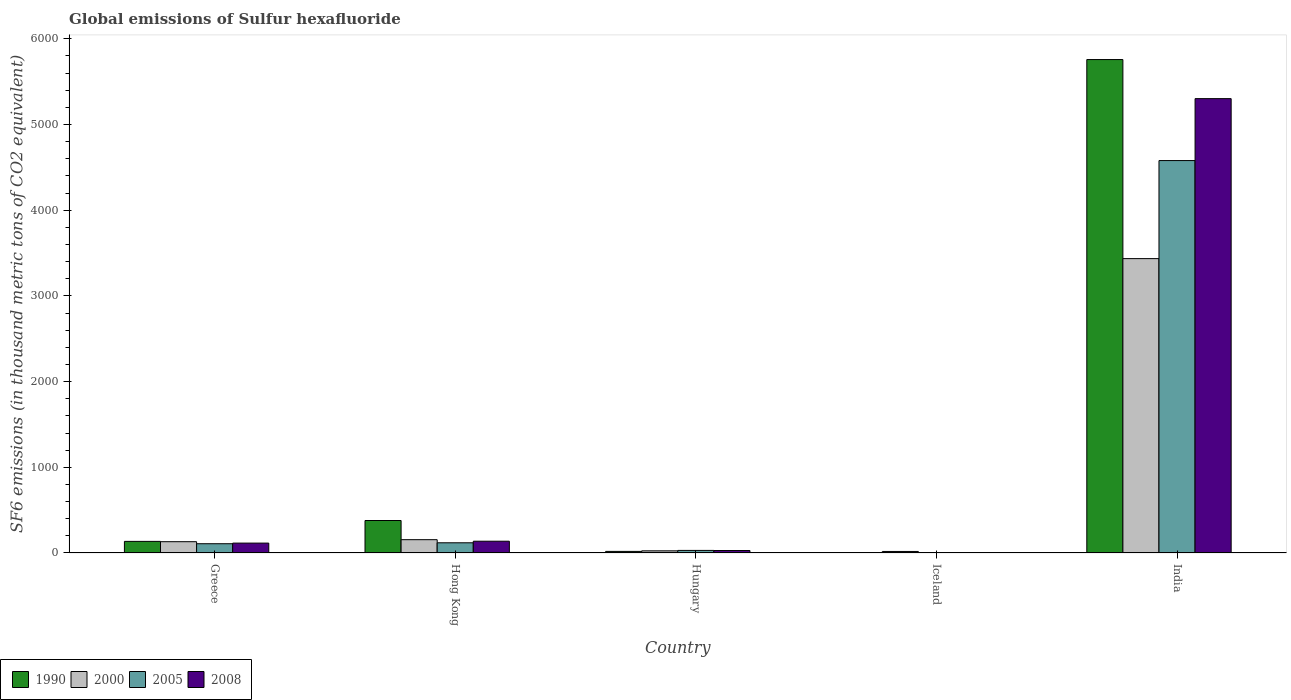How many groups of bars are there?
Provide a succinct answer. 5. Are the number of bars per tick equal to the number of legend labels?
Provide a short and direct response. Yes. How many bars are there on the 1st tick from the right?
Your answer should be compact. 4. What is the label of the 3rd group of bars from the left?
Your answer should be very brief. Hungary. What is the global emissions of Sulfur hexafluoride in 2005 in Iceland?
Ensure brevity in your answer.  3.5. Across all countries, what is the maximum global emissions of Sulfur hexafluoride in 2008?
Give a very brief answer. 5301.4. What is the total global emissions of Sulfur hexafluoride in 2000 in the graph?
Ensure brevity in your answer.  3764.9. What is the difference between the global emissions of Sulfur hexafluoride in 2008 in Greece and that in Hungary?
Provide a succinct answer. 86.5. What is the difference between the global emissions of Sulfur hexafluoride in 2005 in Greece and the global emissions of Sulfur hexafluoride in 1990 in India?
Your response must be concise. -5649.4. What is the average global emissions of Sulfur hexafluoride in 2008 per country?
Offer a terse response. 1117.42. What is the difference between the global emissions of Sulfur hexafluoride of/in 2008 and global emissions of Sulfur hexafluoride of/in 1990 in Hungary?
Your answer should be compact. 10.3. In how many countries, is the global emissions of Sulfur hexafluoride in 2000 greater than 800 thousand metric tons?
Provide a short and direct response. 1. What is the ratio of the global emissions of Sulfur hexafluoride in 2000 in Hong Kong to that in India?
Provide a succinct answer. 0.05. Is the global emissions of Sulfur hexafluoride in 2008 in Hungary less than that in Iceland?
Your answer should be very brief. No. Is the difference between the global emissions of Sulfur hexafluoride in 2008 in Hong Kong and India greater than the difference between the global emissions of Sulfur hexafluoride in 1990 in Hong Kong and India?
Keep it short and to the point. Yes. What is the difference between the highest and the second highest global emissions of Sulfur hexafluoride in 2000?
Give a very brief answer. 3279.4. What is the difference between the highest and the lowest global emissions of Sulfur hexafluoride in 2008?
Your response must be concise. 5297.4. In how many countries, is the global emissions of Sulfur hexafluoride in 2005 greater than the average global emissions of Sulfur hexafluoride in 2005 taken over all countries?
Give a very brief answer. 1. Is the sum of the global emissions of Sulfur hexafluoride in 2005 in Hong Kong and Hungary greater than the maximum global emissions of Sulfur hexafluoride in 2008 across all countries?
Offer a very short reply. No. What does the 3rd bar from the left in Greece represents?
Ensure brevity in your answer.  2005. What does the 1st bar from the right in India represents?
Make the answer very short. 2008. Does the graph contain any zero values?
Offer a terse response. No. What is the title of the graph?
Make the answer very short. Global emissions of Sulfur hexafluoride. What is the label or title of the Y-axis?
Keep it short and to the point. SF6 emissions (in thousand metric tons of CO2 equivalent). What is the SF6 emissions (in thousand metric tons of CO2 equivalent) of 1990 in Greece?
Provide a short and direct response. 135.4. What is the SF6 emissions (in thousand metric tons of CO2 equivalent) of 2000 in Greece?
Your response must be concise. 131.8. What is the SF6 emissions (in thousand metric tons of CO2 equivalent) in 2005 in Greece?
Offer a terse response. 108.1. What is the SF6 emissions (in thousand metric tons of CO2 equivalent) in 2008 in Greece?
Your answer should be compact. 115.4. What is the SF6 emissions (in thousand metric tons of CO2 equivalent) of 1990 in Hong Kong?
Give a very brief answer. 379. What is the SF6 emissions (in thousand metric tons of CO2 equivalent) in 2000 in Hong Kong?
Ensure brevity in your answer.  155.3. What is the SF6 emissions (in thousand metric tons of CO2 equivalent) of 2005 in Hong Kong?
Ensure brevity in your answer.  119. What is the SF6 emissions (in thousand metric tons of CO2 equivalent) in 2008 in Hong Kong?
Ensure brevity in your answer.  137.4. What is the SF6 emissions (in thousand metric tons of CO2 equivalent) of 1990 in Hungary?
Offer a very short reply. 18.6. What is the SF6 emissions (in thousand metric tons of CO2 equivalent) of 2000 in Hungary?
Your answer should be very brief. 25.2. What is the SF6 emissions (in thousand metric tons of CO2 equivalent) in 2008 in Hungary?
Offer a terse response. 28.9. What is the SF6 emissions (in thousand metric tons of CO2 equivalent) of 2000 in Iceland?
Your response must be concise. 17.9. What is the SF6 emissions (in thousand metric tons of CO2 equivalent) of 1990 in India?
Offer a very short reply. 5757.5. What is the SF6 emissions (in thousand metric tons of CO2 equivalent) of 2000 in India?
Your response must be concise. 3434.7. What is the SF6 emissions (in thousand metric tons of CO2 equivalent) of 2005 in India?
Provide a short and direct response. 4578.7. What is the SF6 emissions (in thousand metric tons of CO2 equivalent) of 2008 in India?
Ensure brevity in your answer.  5301.4. Across all countries, what is the maximum SF6 emissions (in thousand metric tons of CO2 equivalent) in 1990?
Your response must be concise. 5757.5. Across all countries, what is the maximum SF6 emissions (in thousand metric tons of CO2 equivalent) in 2000?
Provide a succinct answer. 3434.7. Across all countries, what is the maximum SF6 emissions (in thousand metric tons of CO2 equivalent) in 2005?
Offer a terse response. 4578.7. Across all countries, what is the maximum SF6 emissions (in thousand metric tons of CO2 equivalent) in 2008?
Your answer should be compact. 5301.4. Across all countries, what is the minimum SF6 emissions (in thousand metric tons of CO2 equivalent) in 2005?
Ensure brevity in your answer.  3.5. What is the total SF6 emissions (in thousand metric tons of CO2 equivalent) of 1990 in the graph?
Provide a short and direct response. 6294. What is the total SF6 emissions (in thousand metric tons of CO2 equivalent) of 2000 in the graph?
Make the answer very short. 3764.9. What is the total SF6 emissions (in thousand metric tons of CO2 equivalent) in 2005 in the graph?
Keep it short and to the point. 4839.3. What is the total SF6 emissions (in thousand metric tons of CO2 equivalent) in 2008 in the graph?
Your response must be concise. 5587.1. What is the difference between the SF6 emissions (in thousand metric tons of CO2 equivalent) in 1990 in Greece and that in Hong Kong?
Your answer should be compact. -243.6. What is the difference between the SF6 emissions (in thousand metric tons of CO2 equivalent) of 2000 in Greece and that in Hong Kong?
Ensure brevity in your answer.  -23.5. What is the difference between the SF6 emissions (in thousand metric tons of CO2 equivalent) in 2005 in Greece and that in Hong Kong?
Your answer should be very brief. -10.9. What is the difference between the SF6 emissions (in thousand metric tons of CO2 equivalent) of 2008 in Greece and that in Hong Kong?
Your response must be concise. -22. What is the difference between the SF6 emissions (in thousand metric tons of CO2 equivalent) in 1990 in Greece and that in Hungary?
Your response must be concise. 116.8. What is the difference between the SF6 emissions (in thousand metric tons of CO2 equivalent) in 2000 in Greece and that in Hungary?
Your response must be concise. 106.6. What is the difference between the SF6 emissions (in thousand metric tons of CO2 equivalent) in 2005 in Greece and that in Hungary?
Your answer should be very brief. 78.1. What is the difference between the SF6 emissions (in thousand metric tons of CO2 equivalent) of 2008 in Greece and that in Hungary?
Provide a succinct answer. 86.5. What is the difference between the SF6 emissions (in thousand metric tons of CO2 equivalent) in 1990 in Greece and that in Iceland?
Offer a very short reply. 131.9. What is the difference between the SF6 emissions (in thousand metric tons of CO2 equivalent) in 2000 in Greece and that in Iceland?
Provide a short and direct response. 113.9. What is the difference between the SF6 emissions (in thousand metric tons of CO2 equivalent) of 2005 in Greece and that in Iceland?
Offer a very short reply. 104.6. What is the difference between the SF6 emissions (in thousand metric tons of CO2 equivalent) in 2008 in Greece and that in Iceland?
Offer a very short reply. 111.4. What is the difference between the SF6 emissions (in thousand metric tons of CO2 equivalent) in 1990 in Greece and that in India?
Offer a terse response. -5622.1. What is the difference between the SF6 emissions (in thousand metric tons of CO2 equivalent) in 2000 in Greece and that in India?
Provide a succinct answer. -3302.9. What is the difference between the SF6 emissions (in thousand metric tons of CO2 equivalent) in 2005 in Greece and that in India?
Offer a very short reply. -4470.6. What is the difference between the SF6 emissions (in thousand metric tons of CO2 equivalent) of 2008 in Greece and that in India?
Offer a very short reply. -5186. What is the difference between the SF6 emissions (in thousand metric tons of CO2 equivalent) of 1990 in Hong Kong and that in Hungary?
Make the answer very short. 360.4. What is the difference between the SF6 emissions (in thousand metric tons of CO2 equivalent) of 2000 in Hong Kong and that in Hungary?
Provide a short and direct response. 130.1. What is the difference between the SF6 emissions (in thousand metric tons of CO2 equivalent) of 2005 in Hong Kong and that in Hungary?
Make the answer very short. 89. What is the difference between the SF6 emissions (in thousand metric tons of CO2 equivalent) of 2008 in Hong Kong and that in Hungary?
Offer a terse response. 108.5. What is the difference between the SF6 emissions (in thousand metric tons of CO2 equivalent) of 1990 in Hong Kong and that in Iceland?
Offer a very short reply. 375.5. What is the difference between the SF6 emissions (in thousand metric tons of CO2 equivalent) in 2000 in Hong Kong and that in Iceland?
Give a very brief answer. 137.4. What is the difference between the SF6 emissions (in thousand metric tons of CO2 equivalent) of 2005 in Hong Kong and that in Iceland?
Offer a very short reply. 115.5. What is the difference between the SF6 emissions (in thousand metric tons of CO2 equivalent) in 2008 in Hong Kong and that in Iceland?
Give a very brief answer. 133.4. What is the difference between the SF6 emissions (in thousand metric tons of CO2 equivalent) in 1990 in Hong Kong and that in India?
Make the answer very short. -5378.5. What is the difference between the SF6 emissions (in thousand metric tons of CO2 equivalent) of 2000 in Hong Kong and that in India?
Your answer should be compact. -3279.4. What is the difference between the SF6 emissions (in thousand metric tons of CO2 equivalent) in 2005 in Hong Kong and that in India?
Provide a succinct answer. -4459.7. What is the difference between the SF6 emissions (in thousand metric tons of CO2 equivalent) in 2008 in Hong Kong and that in India?
Offer a very short reply. -5164. What is the difference between the SF6 emissions (in thousand metric tons of CO2 equivalent) in 1990 in Hungary and that in Iceland?
Offer a very short reply. 15.1. What is the difference between the SF6 emissions (in thousand metric tons of CO2 equivalent) of 2000 in Hungary and that in Iceland?
Your response must be concise. 7.3. What is the difference between the SF6 emissions (in thousand metric tons of CO2 equivalent) of 2005 in Hungary and that in Iceland?
Make the answer very short. 26.5. What is the difference between the SF6 emissions (in thousand metric tons of CO2 equivalent) of 2008 in Hungary and that in Iceland?
Keep it short and to the point. 24.9. What is the difference between the SF6 emissions (in thousand metric tons of CO2 equivalent) in 1990 in Hungary and that in India?
Your response must be concise. -5738.9. What is the difference between the SF6 emissions (in thousand metric tons of CO2 equivalent) of 2000 in Hungary and that in India?
Offer a very short reply. -3409.5. What is the difference between the SF6 emissions (in thousand metric tons of CO2 equivalent) in 2005 in Hungary and that in India?
Your response must be concise. -4548.7. What is the difference between the SF6 emissions (in thousand metric tons of CO2 equivalent) in 2008 in Hungary and that in India?
Your response must be concise. -5272.5. What is the difference between the SF6 emissions (in thousand metric tons of CO2 equivalent) in 1990 in Iceland and that in India?
Your response must be concise. -5754. What is the difference between the SF6 emissions (in thousand metric tons of CO2 equivalent) in 2000 in Iceland and that in India?
Make the answer very short. -3416.8. What is the difference between the SF6 emissions (in thousand metric tons of CO2 equivalent) of 2005 in Iceland and that in India?
Your response must be concise. -4575.2. What is the difference between the SF6 emissions (in thousand metric tons of CO2 equivalent) in 2008 in Iceland and that in India?
Make the answer very short. -5297.4. What is the difference between the SF6 emissions (in thousand metric tons of CO2 equivalent) in 1990 in Greece and the SF6 emissions (in thousand metric tons of CO2 equivalent) in 2000 in Hong Kong?
Your answer should be compact. -19.9. What is the difference between the SF6 emissions (in thousand metric tons of CO2 equivalent) of 1990 in Greece and the SF6 emissions (in thousand metric tons of CO2 equivalent) of 2005 in Hong Kong?
Offer a terse response. 16.4. What is the difference between the SF6 emissions (in thousand metric tons of CO2 equivalent) of 1990 in Greece and the SF6 emissions (in thousand metric tons of CO2 equivalent) of 2008 in Hong Kong?
Give a very brief answer. -2. What is the difference between the SF6 emissions (in thousand metric tons of CO2 equivalent) of 2000 in Greece and the SF6 emissions (in thousand metric tons of CO2 equivalent) of 2005 in Hong Kong?
Offer a terse response. 12.8. What is the difference between the SF6 emissions (in thousand metric tons of CO2 equivalent) of 2005 in Greece and the SF6 emissions (in thousand metric tons of CO2 equivalent) of 2008 in Hong Kong?
Ensure brevity in your answer.  -29.3. What is the difference between the SF6 emissions (in thousand metric tons of CO2 equivalent) in 1990 in Greece and the SF6 emissions (in thousand metric tons of CO2 equivalent) in 2000 in Hungary?
Ensure brevity in your answer.  110.2. What is the difference between the SF6 emissions (in thousand metric tons of CO2 equivalent) in 1990 in Greece and the SF6 emissions (in thousand metric tons of CO2 equivalent) in 2005 in Hungary?
Give a very brief answer. 105.4. What is the difference between the SF6 emissions (in thousand metric tons of CO2 equivalent) in 1990 in Greece and the SF6 emissions (in thousand metric tons of CO2 equivalent) in 2008 in Hungary?
Keep it short and to the point. 106.5. What is the difference between the SF6 emissions (in thousand metric tons of CO2 equivalent) of 2000 in Greece and the SF6 emissions (in thousand metric tons of CO2 equivalent) of 2005 in Hungary?
Make the answer very short. 101.8. What is the difference between the SF6 emissions (in thousand metric tons of CO2 equivalent) in 2000 in Greece and the SF6 emissions (in thousand metric tons of CO2 equivalent) in 2008 in Hungary?
Offer a terse response. 102.9. What is the difference between the SF6 emissions (in thousand metric tons of CO2 equivalent) of 2005 in Greece and the SF6 emissions (in thousand metric tons of CO2 equivalent) of 2008 in Hungary?
Your answer should be very brief. 79.2. What is the difference between the SF6 emissions (in thousand metric tons of CO2 equivalent) of 1990 in Greece and the SF6 emissions (in thousand metric tons of CO2 equivalent) of 2000 in Iceland?
Offer a very short reply. 117.5. What is the difference between the SF6 emissions (in thousand metric tons of CO2 equivalent) of 1990 in Greece and the SF6 emissions (in thousand metric tons of CO2 equivalent) of 2005 in Iceland?
Offer a very short reply. 131.9. What is the difference between the SF6 emissions (in thousand metric tons of CO2 equivalent) of 1990 in Greece and the SF6 emissions (in thousand metric tons of CO2 equivalent) of 2008 in Iceland?
Give a very brief answer. 131.4. What is the difference between the SF6 emissions (in thousand metric tons of CO2 equivalent) of 2000 in Greece and the SF6 emissions (in thousand metric tons of CO2 equivalent) of 2005 in Iceland?
Your answer should be compact. 128.3. What is the difference between the SF6 emissions (in thousand metric tons of CO2 equivalent) of 2000 in Greece and the SF6 emissions (in thousand metric tons of CO2 equivalent) of 2008 in Iceland?
Ensure brevity in your answer.  127.8. What is the difference between the SF6 emissions (in thousand metric tons of CO2 equivalent) of 2005 in Greece and the SF6 emissions (in thousand metric tons of CO2 equivalent) of 2008 in Iceland?
Your answer should be compact. 104.1. What is the difference between the SF6 emissions (in thousand metric tons of CO2 equivalent) in 1990 in Greece and the SF6 emissions (in thousand metric tons of CO2 equivalent) in 2000 in India?
Your answer should be very brief. -3299.3. What is the difference between the SF6 emissions (in thousand metric tons of CO2 equivalent) in 1990 in Greece and the SF6 emissions (in thousand metric tons of CO2 equivalent) in 2005 in India?
Your answer should be very brief. -4443.3. What is the difference between the SF6 emissions (in thousand metric tons of CO2 equivalent) in 1990 in Greece and the SF6 emissions (in thousand metric tons of CO2 equivalent) in 2008 in India?
Keep it short and to the point. -5166. What is the difference between the SF6 emissions (in thousand metric tons of CO2 equivalent) in 2000 in Greece and the SF6 emissions (in thousand metric tons of CO2 equivalent) in 2005 in India?
Offer a terse response. -4446.9. What is the difference between the SF6 emissions (in thousand metric tons of CO2 equivalent) in 2000 in Greece and the SF6 emissions (in thousand metric tons of CO2 equivalent) in 2008 in India?
Offer a very short reply. -5169.6. What is the difference between the SF6 emissions (in thousand metric tons of CO2 equivalent) in 2005 in Greece and the SF6 emissions (in thousand metric tons of CO2 equivalent) in 2008 in India?
Give a very brief answer. -5193.3. What is the difference between the SF6 emissions (in thousand metric tons of CO2 equivalent) of 1990 in Hong Kong and the SF6 emissions (in thousand metric tons of CO2 equivalent) of 2000 in Hungary?
Provide a short and direct response. 353.8. What is the difference between the SF6 emissions (in thousand metric tons of CO2 equivalent) in 1990 in Hong Kong and the SF6 emissions (in thousand metric tons of CO2 equivalent) in 2005 in Hungary?
Offer a terse response. 349. What is the difference between the SF6 emissions (in thousand metric tons of CO2 equivalent) of 1990 in Hong Kong and the SF6 emissions (in thousand metric tons of CO2 equivalent) of 2008 in Hungary?
Make the answer very short. 350.1. What is the difference between the SF6 emissions (in thousand metric tons of CO2 equivalent) of 2000 in Hong Kong and the SF6 emissions (in thousand metric tons of CO2 equivalent) of 2005 in Hungary?
Provide a short and direct response. 125.3. What is the difference between the SF6 emissions (in thousand metric tons of CO2 equivalent) of 2000 in Hong Kong and the SF6 emissions (in thousand metric tons of CO2 equivalent) of 2008 in Hungary?
Offer a very short reply. 126.4. What is the difference between the SF6 emissions (in thousand metric tons of CO2 equivalent) of 2005 in Hong Kong and the SF6 emissions (in thousand metric tons of CO2 equivalent) of 2008 in Hungary?
Give a very brief answer. 90.1. What is the difference between the SF6 emissions (in thousand metric tons of CO2 equivalent) in 1990 in Hong Kong and the SF6 emissions (in thousand metric tons of CO2 equivalent) in 2000 in Iceland?
Provide a short and direct response. 361.1. What is the difference between the SF6 emissions (in thousand metric tons of CO2 equivalent) of 1990 in Hong Kong and the SF6 emissions (in thousand metric tons of CO2 equivalent) of 2005 in Iceland?
Your answer should be compact. 375.5. What is the difference between the SF6 emissions (in thousand metric tons of CO2 equivalent) in 1990 in Hong Kong and the SF6 emissions (in thousand metric tons of CO2 equivalent) in 2008 in Iceland?
Your answer should be very brief. 375. What is the difference between the SF6 emissions (in thousand metric tons of CO2 equivalent) in 2000 in Hong Kong and the SF6 emissions (in thousand metric tons of CO2 equivalent) in 2005 in Iceland?
Offer a very short reply. 151.8. What is the difference between the SF6 emissions (in thousand metric tons of CO2 equivalent) of 2000 in Hong Kong and the SF6 emissions (in thousand metric tons of CO2 equivalent) of 2008 in Iceland?
Make the answer very short. 151.3. What is the difference between the SF6 emissions (in thousand metric tons of CO2 equivalent) of 2005 in Hong Kong and the SF6 emissions (in thousand metric tons of CO2 equivalent) of 2008 in Iceland?
Your response must be concise. 115. What is the difference between the SF6 emissions (in thousand metric tons of CO2 equivalent) in 1990 in Hong Kong and the SF6 emissions (in thousand metric tons of CO2 equivalent) in 2000 in India?
Give a very brief answer. -3055.7. What is the difference between the SF6 emissions (in thousand metric tons of CO2 equivalent) in 1990 in Hong Kong and the SF6 emissions (in thousand metric tons of CO2 equivalent) in 2005 in India?
Offer a very short reply. -4199.7. What is the difference between the SF6 emissions (in thousand metric tons of CO2 equivalent) of 1990 in Hong Kong and the SF6 emissions (in thousand metric tons of CO2 equivalent) of 2008 in India?
Offer a terse response. -4922.4. What is the difference between the SF6 emissions (in thousand metric tons of CO2 equivalent) of 2000 in Hong Kong and the SF6 emissions (in thousand metric tons of CO2 equivalent) of 2005 in India?
Your answer should be very brief. -4423.4. What is the difference between the SF6 emissions (in thousand metric tons of CO2 equivalent) in 2000 in Hong Kong and the SF6 emissions (in thousand metric tons of CO2 equivalent) in 2008 in India?
Provide a succinct answer. -5146.1. What is the difference between the SF6 emissions (in thousand metric tons of CO2 equivalent) in 2005 in Hong Kong and the SF6 emissions (in thousand metric tons of CO2 equivalent) in 2008 in India?
Provide a short and direct response. -5182.4. What is the difference between the SF6 emissions (in thousand metric tons of CO2 equivalent) in 1990 in Hungary and the SF6 emissions (in thousand metric tons of CO2 equivalent) in 2005 in Iceland?
Your answer should be very brief. 15.1. What is the difference between the SF6 emissions (in thousand metric tons of CO2 equivalent) of 1990 in Hungary and the SF6 emissions (in thousand metric tons of CO2 equivalent) of 2008 in Iceland?
Your answer should be compact. 14.6. What is the difference between the SF6 emissions (in thousand metric tons of CO2 equivalent) of 2000 in Hungary and the SF6 emissions (in thousand metric tons of CO2 equivalent) of 2005 in Iceland?
Offer a very short reply. 21.7. What is the difference between the SF6 emissions (in thousand metric tons of CO2 equivalent) in 2000 in Hungary and the SF6 emissions (in thousand metric tons of CO2 equivalent) in 2008 in Iceland?
Keep it short and to the point. 21.2. What is the difference between the SF6 emissions (in thousand metric tons of CO2 equivalent) of 1990 in Hungary and the SF6 emissions (in thousand metric tons of CO2 equivalent) of 2000 in India?
Make the answer very short. -3416.1. What is the difference between the SF6 emissions (in thousand metric tons of CO2 equivalent) of 1990 in Hungary and the SF6 emissions (in thousand metric tons of CO2 equivalent) of 2005 in India?
Make the answer very short. -4560.1. What is the difference between the SF6 emissions (in thousand metric tons of CO2 equivalent) of 1990 in Hungary and the SF6 emissions (in thousand metric tons of CO2 equivalent) of 2008 in India?
Ensure brevity in your answer.  -5282.8. What is the difference between the SF6 emissions (in thousand metric tons of CO2 equivalent) of 2000 in Hungary and the SF6 emissions (in thousand metric tons of CO2 equivalent) of 2005 in India?
Give a very brief answer. -4553.5. What is the difference between the SF6 emissions (in thousand metric tons of CO2 equivalent) in 2000 in Hungary and the SF6 emissions (in thousand metric tons of CO2 equivalent) in 2008 in India?
Offer a very short reply. -5276.2. What is the difference between the SF6 emissions (in thousand metric tons of CO2 equivalent) in 2005 in Hungary and the SF6 emissions (in thousand metric tons of CO2 equivalent) in 2008 in India?
Your response must be concise. -5271.4. What is the difference between the SF6 emissions (in thousand metric tons of CO2 equivalent) in 1990 in Iceland and the SF6 emissions (in thousand metric tons of CO2 equivalent) in 2000 in India?
Your answer should be very brief. -3431.2. What is the difference between the SF6 emissions (in thousand metric tons of CO2 equivalent) of 1990 in Iceland and the SF6 emissions (in thousand metric tons of CO2 equivalent) of 2005 in India?
Your response must be concise. -4575.2. What is the difference between the SF6 emissions (in thousand metric tons of CO2 equivalent) in 1990 in Iceland and the SF6 emissions (in thousand metric tons of CO2 equivalent) in 2008 in India?
Your answer should be very brief. -5297.9. What is the difference between the SF6 emissions (in thousand metric tons of CO2 equivalent) in 2000 in Iceland and the SF6 emissions (in thousand metric tons of CO2 equivalent) in 2005 in India?
Keep it short and to the point. -4560.8. What is the difference between the SF6 emissions (in thousand metric tons of CO2 equivalent) in 2000 in Iceland and the SF6 emissions (in thousand metric tons of CO2 equivalent) in 2008 in India?
Offer a very short reply. -5283.5. What is the difference between the SF6 emissions (in thousand metric tons of CO2 equivalent) of 2005 in Iceland and the SF6 emissions (in thousand metric tons of CO2 equivalent) of 2008 in India?
Give a very brief answer. -5297.9. What is the average SF6 emissions (in thousand metric tons of CO2 equivalent) in 1990 per country?
Your answer should be compact. 1258.8. What is the average SF6 emissions (in thousand metric tons of CO2 equivalent) in 2000 per country?
Offer a terse response. 752.98. What is the average SF6 emissions (in thousand metric tons of CO2 equivalent) of 2005 per country?
Give a very brief answer. 967.86. What is the average SF6 emissions (in thousand metric tons of CO2 equivalent) of 2008 per country?
Provide a succinct answer. 1117.42. What is the difference between the SF6 emissions (in thousand metric tons of CO2 equivalent) of 1990 and SF6 emissions (in thousand metric tons of CO2 equivalent) of 2005 in Greece?
Ensure brevity in your answer.  27.3. What is the difference between the SF6 emissions (in thousand metric tons of CO2 equivalent) of 2000 and SF6 emissions (in thousand metric tons of CO2 equivalent) of 2005 in Greece?
Keep it short and to the point. 23.7. What is the difference between the SF6 emissions (in thousand metric tons of CO2 equivalent) in 2005 and SF6 emissions (in thousand metric tons of CO2 equivalent) in 2008 in Greece?
Provide a succinct answer. -7.3. What is the difference between the SF6 emissions (in thousand metric tons of CO2 equivalent) of 1990 and SF6 emissions (in thousand metric tons of CO2 equivalent) of 2000 in Hong Kong?
Provide a succinct answer. 223.7. What is the difference between the SF6 emissions (in thousand metric tons of CO2 equivalent) of 1990 and SF6 emissions (in thousand metric tons of CO2 equivalent) of 2005 in Hong Kong?
Ensure brevity in your answer.  260. What is the difference between the SF6 emissions (in thousand metric tons of CO2 equivalent) of 1990 and SF6 emissions (in thousand metric tons of CO2 equivalent) of 2008 in Hong Kong?
Offer a very short reply. 241.6. What is the difference between the SF6 emissions (in thousand metric tons of CO2 equivalent) of 2000 and SF6 emissions (in thousand metric tons of CO2 equivalent) of 2005 in Hong Kong?
Your response must be concise. 36.3. What is the difference between the SF6 emissions (in thousand metric tons of CO2 equivalent) of 2000 and SF6 emissions (in thousand metric tons of CO2 equivalent) of 2008 in Hong Kong?
Your response must be concise. 17.9. What is the difference between the SF6 emissions (in thousand metric tons of CO2 equivalent) of 2005 and SF6 emissions (in thousand metric tons of CO2 equivalent) of 2008 in Hong Kong?
Offer a very short reply. -18.4. What is the difference between the SF6 emissions (in thousand metric tons of CO2 equivalent) of 1990 and SF6 emissions (in thousand metric tons of CO2 equivalent) of 2000 in Hungary?
Your answer should be compact. -6.6. What is the difference between the SF6 emissions (in thousand metric tons of CO2 equivalent) in 1990 and SF6 emissions (in thousand metric tons of CO2 equivalent) in 2005 in Hungary?
Make the answer very short. -11.4. What is the difference between the SF6 emissions (in thousand metric tons of CO2 equivalent) in 2000 and SF6 emissions (in thousand metric tons of CO2 equivalent) in 2008 in Hungary?
Provide a succinct answer. -3.7. What is the difference between the SF6 emissions (in thousand metric tons of CO2 equivalent) in 2005 and SF6 emissions (in thousand metric tons of CO2 equivalent) in 2008 in Hungary?
Provide a succinct answer. 1.1. What is the difference between the SF6 emissions (in thousand metric tons of CO2 equivalent) of 1990 and SF6 emissions (in thousand metric tons of CO2 equivalent) of 2000 in Iceland?
Offer a very short reply. -14.4. What is the difference between the SF6 emissions (in thousand metric tons of CO2 equivalent) of 1990 and SF6 emissions (in thousand metric tons of CO2 equivalent) of 2008 in Iceland?
Your answer should be very brief. -0.5. What is the difference between the SF6 emissions (in thousand metric tons of CO2 equivalent) of 2000 and SF6 emissions (in thousand metric tons of CO2 equivalent) of 2005 in Iceland?
Your answer should be compact. 14.4. What is the difference between the SF6 emissions (in thousand metric tons of CO2 equivalent) in 2000 and SF6 emissions (in thousand metric tons of CO2 equivalent) in 2008 in Iceland?
Provide a short and direct response. 13.9. What is the difference between the SF6 emissions (in thousand metric tons of CO2 equivalent) in 1990 and SF6 emissions (in thousand metric tons of CO2 equivalent) in 2000 in India?
Your response must be concise. 2322.8. What is the difference between the SF6 emissions (in thousand metric tons of CO2 equivalent) in 1990 and SF6 emissions (in thousand metric tons of CO2 equivalent) in 2005 in India?
Provide a succinct answer. 1178.8. What is the difference between the SF6 emissions (in thousand metric tons of CO2 equivalent) in 1990 and SF6 emissions (in thousand metric tons of CO2 equivalent) in 2008 in India?
Your answer should be compact. 456.1. What is the difference between the SF6 emissions (in thousand metric tons of CO2 equivalent) in 2000 and SF6 emissions (in thousand metric tons of CO2 equivalent) in 2005 in India?
Provide a succinct answer. -1144. What is the difference between the SF6 emissions (in thousand metric tons of CO2 equivalent) of 2000 and SF6 emissions (in thousand metric tons of CO2 equivalent) of 2008 in India?
Keep it short and to the point. -1866.7. What is the difference between the SF6 emissions (in thousand metric tons of CO2 equivalent) of 2005 and SF6 emissions (in thousand metric tons of CO2 equivalent) of 2008 in India?
Your answer should be very brief. -722.7. What is the ratio of the SF6 emissions (in thousand metric tons of CO2 equivalent) in 1990 in Greece to that in Hong Kong?
Ensure brevity in your answer.  0.36. What is the ratio of the SF6 emissions (in thousand metric tons of CO2 equivalent) of 2000 in Greece to that in Hong Kong?
Offer a very short reply. 0.85. What is the ratio of the SF6 emissions (in thousand metric tons of CO2 equivalent) in 2005 in Greece to that in Hong Kong?
Your answer should be compact. 0.91. What is the ratio of the SF6 emissions (in thousand metric tons of CO2 equivalent) in 2008 in Greece to that in Hong Kong?
Give a very brief answer. 0.84. What is the ratio of the SF6 emissions (in thousand metric tons of CO2 equivalent) in 1990 in Greece to that in Hungary?
Keep it short and to the point. 7.28. What is the ratio of the SF6 emissions (in thousand metric tons of CO2 equivalent) in 2000 in Greece to that in Hungary?
Give a very brief answer. 5.23. What is the ratio of the SF6 emissions (in thousand metric tons of CO2 equivalent) in 2005 in Greece to that in Hungary?
Your answer should be very brief. 3.6. What is the ratio of the SF6 emissions (in thousand metric tons of CO2 equivalent) in 2008 in Greece to that in Hungary?
Your response must be concise. 3.99. What is the ratio of the SF6 emissions (in thousand metric tons of CO2 equivalent) of 1990 in Greece to that in Iceland?
Provide a short and direct response. 38.69. What is the ratio of the SF6 emissions (in thousand metric tons of CO2 equivalent) in 2000 in Greece to that in Iceland?
Provide a succinct answer. 7.36. What is the ratio of the SF6 emissions (in thousand metric tons of CO2 equivalent) of 2005 in Greece to that in Iceland?
Keep it short and to the point. 30.89. What is the ratio of the SF6 emissions (in thousand metric tons of CO2 equivalent) of 2008 in Greece to that in Iceland?
Ensure brevity in your answer.  28.85. What is the ratio of the SF6 emissions (in thousand metric tons of CO2 equivalent) of 1990 in Greece to that in India?
Your answer should be very brief. 0.02. What is the ratio of the SF6 emissions (in thousand metric tons of CO2 equivalent) of 2000 in Greece to that in India?
Ensure brevity in your answer.  0.04. What is the ratio of the SF6 emissions (in thousand metric tons of CO2 equivalent) in 2005 in Greece to that in India?
Make the answer very short. 0.02. What is the ratio of the SF6 emissions (in thousand metric tons of CO2 equivalent) in 2008 in Greece to that in India?
Your answer should be compact. 0.02. What is the ratio of the SF6 emissions (in thousand metric tons of CO2 equivalent) of 1990 in Hong Kong to that in Hungary?
Offer a very short reply. 20.38. What is the ratio of the SF6 emissions (in thousand metric tons of CO2 equivalent) in 2000 in Hong Kong to that in Hungary?
Keep it short and to the point. 6.16. What is the ratio of the SF6 emissions (in thousand metric tons of CO2 equivalent) of 2005 in Hong Kong to that in Hungary?
Give a very brief answer. 3.97. What is the ratio of the SF6 emissions (in thousand metric tons of CO2 equivalent) in 2008 in Hong Kong to that in Hungary?
Ensure brevity in your answer.  4.75. What is the ratio of the SF6 emissions (in thousand metric tons of CO2 equivalent) in 1990 in Hong Kong to that in Iceland?
Your answer should be compact. 108.29. What is the ratio of the SF6 emissions (in thousand metric tons of CO2 equivalent) in 2000 in Hong Kong to that in Iceland?
Offer a terse response. 8.68. What is the ratio of the SF6 emissions (in thousand metric tons of CO2 equivalent) in 2008 in Hong Kong to that in Iceland?
Provide a succinct answer. 34.35. What is the ratio of the SF6 emissions (in thousand metric tons of CO2 equivalent) in 1990 in Hong Kong to that in India?
Your answer should be compact. 0.07. What is the ratio of the SF6 emissions (in thousand metric tons of CO2 equivalent) of 2000 in Hong Kong to that in India?
Your answer should be very brief. 0.05. What is the ratio of the SF6 emissions (in thousand metric tons of CO2 equivalent) of 2005 in Hong Kong to that in India?
Offer a terse response. 0.03. What is the ratio of the SF6 emissions (in thousand metric tons of CO2 equivalent) of 2008 in Hong Kong to that in India?
Your answer should be very brief. 0.03. What is the ratio of the SF6 emissions (in thousand metric tons of CO2 equivalent) of 1990 in Hungary to that in Iceland?
Offer a terse response. 5.31. What is the ratio of the SF6 emissions (in thousand metric tons of CO2 equivalent) in 2000 in Hungary to that in Iceland?
Give a very brief answer. 1.41. What is the ratio of the SF6 emissions (in thousand metric tons of CO2 equivalent) in 2005 in Hungary to that in Iceland?
Your answer should be compact. 8.57. What is the ratio of the SF6 emissions (in thousand metric tons of CO2 equivalent) in 2008 in Hungary to that in Iceland?
Your answer should be very brief. 7.22. What is the ratio of the SF6 emissions (in thousand metric tons of CO2 equivalent) of 1990 in Hungary to that in India?
Offer a very short reply. 0. What is the ratio of the SF6 emissions (in thousand metric tons of CO2 equivalent) in 2000 in Hungary to that in India?
Your response must be concise. 0.01. What is the ratio of the SF6 emissions (in thousand metric tons of CO2 equivalent) of 2005 in Hungary to that in India?
Keep it short and to the point. 0.01. What is the ratio of the SF6 emissions (in thousand metric tons of CO2 equivalent) in 2008 in Hungary to that in India?
Provide a short and direct response. 0.01. What is the ratio of the SF6 emissions (in thousand metric tons of CO2 equivalent) in 1990 in Iceland to that in India?
Your answer should be compact. 0. What is the ratio of the SF6 emissions (in thousand metric tons of CO2 equivalent) in 2000 in Iceland to that in India?
Offer a terse response. 0.01. What is the ratio of the SF6 emissions (in thousand metric tons of CO2 equivalent) of 2005 in Iceland to that in India?
Provide a succinct answer. 0. What is the ratio of the SF6 emissions (in thousand metric tons of CO2 equivalent) of 2008 in Iceland to that in India?
Your answer should be compact. 0. What is the difference between the highest and the second highest SF6 emissions (in thousand metric tons of CO2 equivalent) of 1990?
Your answer should be compact. 5378.5. What is the difference between the highest and the second highest SF6 emissions (in thousand metric tons of CO2 equivalent) in 2000?
Offer a very short reply. 3279.4. What is the difference between the highest and the second highest SF6 emissions (in thousand metric tons of CO2 equivalent) of 2005?
Give a very brief answer. 4459.7. What is the difference between the highest and the second highest SF6 emissions (in thousand metric tons of CO2 equivalent) in 2008?
Ensure brevity in your answer.  5164. What is the difference between the highest and the lowest SF6 emissions (in thousand metric tons of CO2 equivalent) of 1990?
Your answer should be very brief. 5754. What is the difference between the highest and the lowest SF6 emissions (in thousand metric tons of CO2 equivalent) in 2000?
Provide a short and direct response. 3416.8. What is the difference between the highest and the lowest SF6 emissions (in thousand metric tons of CO2 equivalent) in 2005?
Provide a succinct answer. 4575.2. What is the difference between the highest and the lowest SF6 emissions (in thousand metric tons of CO2 equivalent) of 2008?
Make the answer very short. 5297.4. 